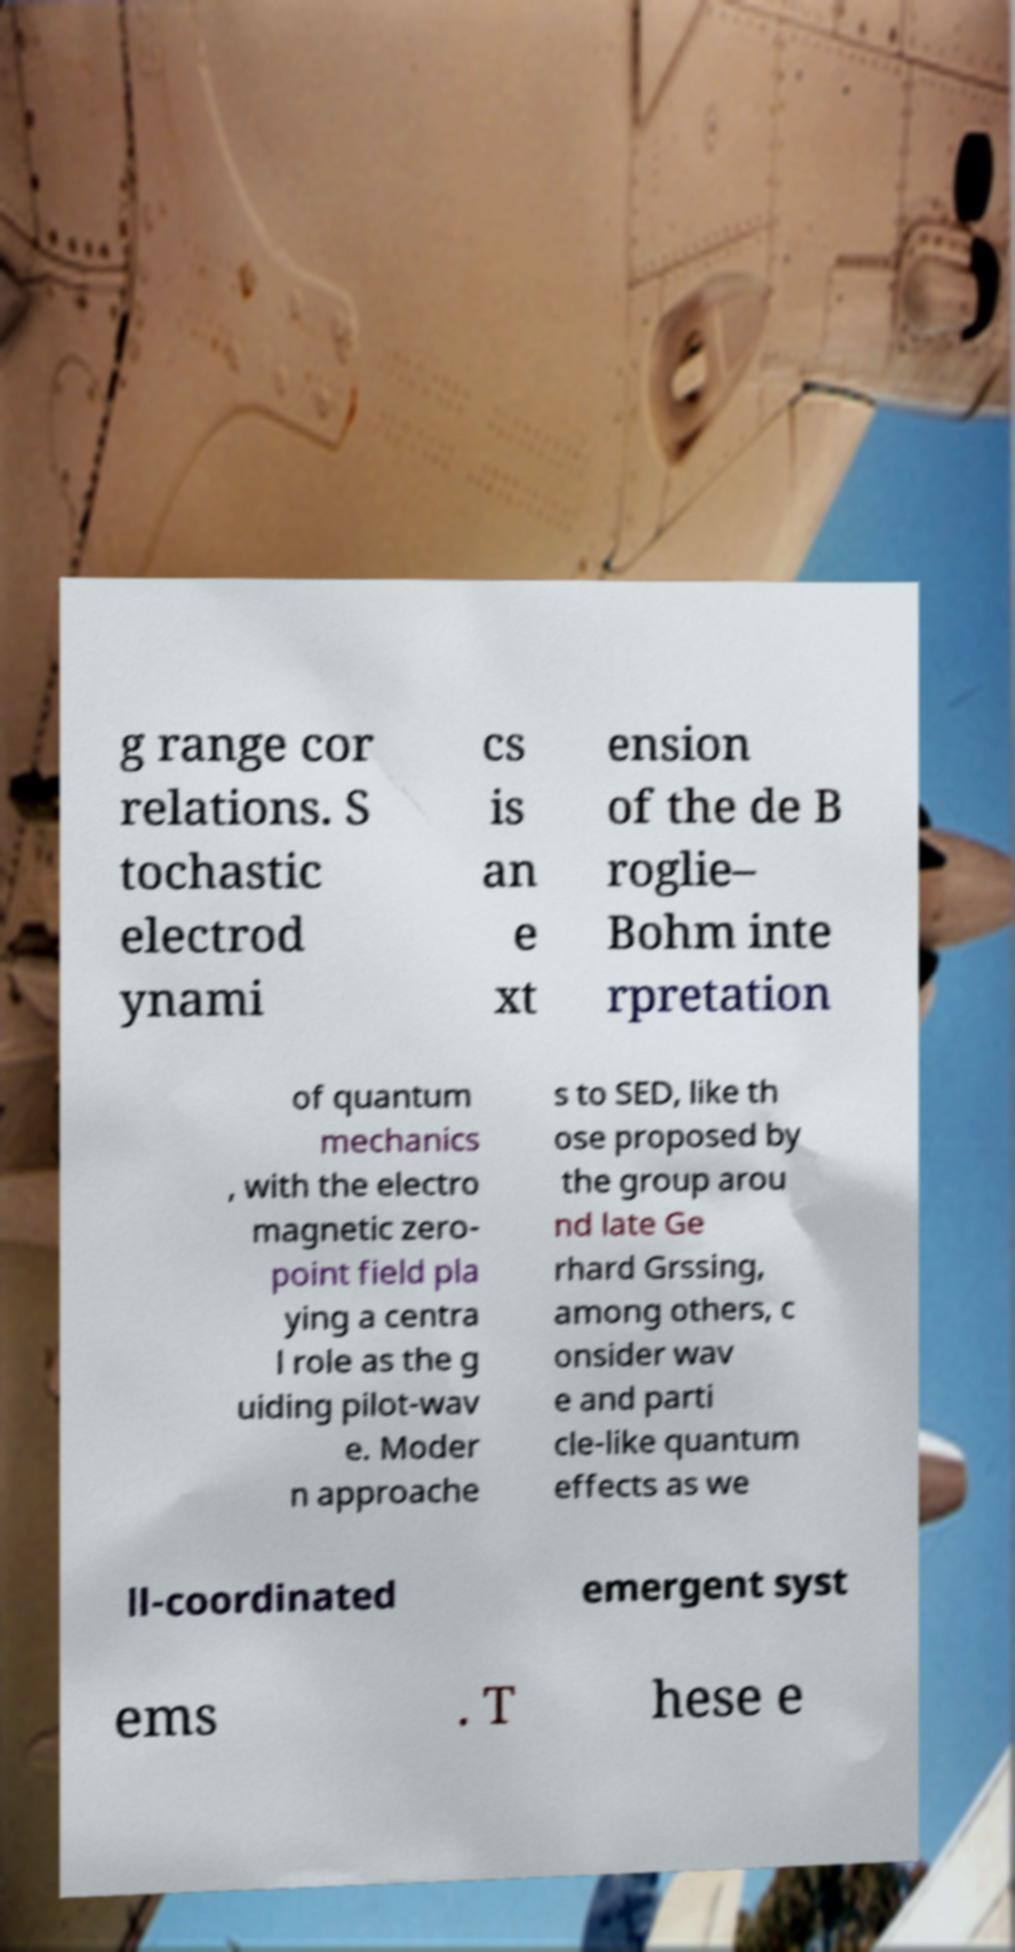Can you read and provide the text displayed in the image?This photo seems to have some interesting text. Can you extract and type it out for me? g range cor relations. S tochastic electrod ynami cs is an e xt ension of the de B roglie– Bohm inte rpretation of quantum mechanics , with the electro magnetic zero- point field pla ying a centra l role as the g uiding pilot-wav e. Moder n approache s to SED, like th ose proposed by the group arou nd late Ge rhard Grssing, among others, c onsider wav e and parti cle-like quantum effects as we ll-coordinated emergent syst ems . T hese e 